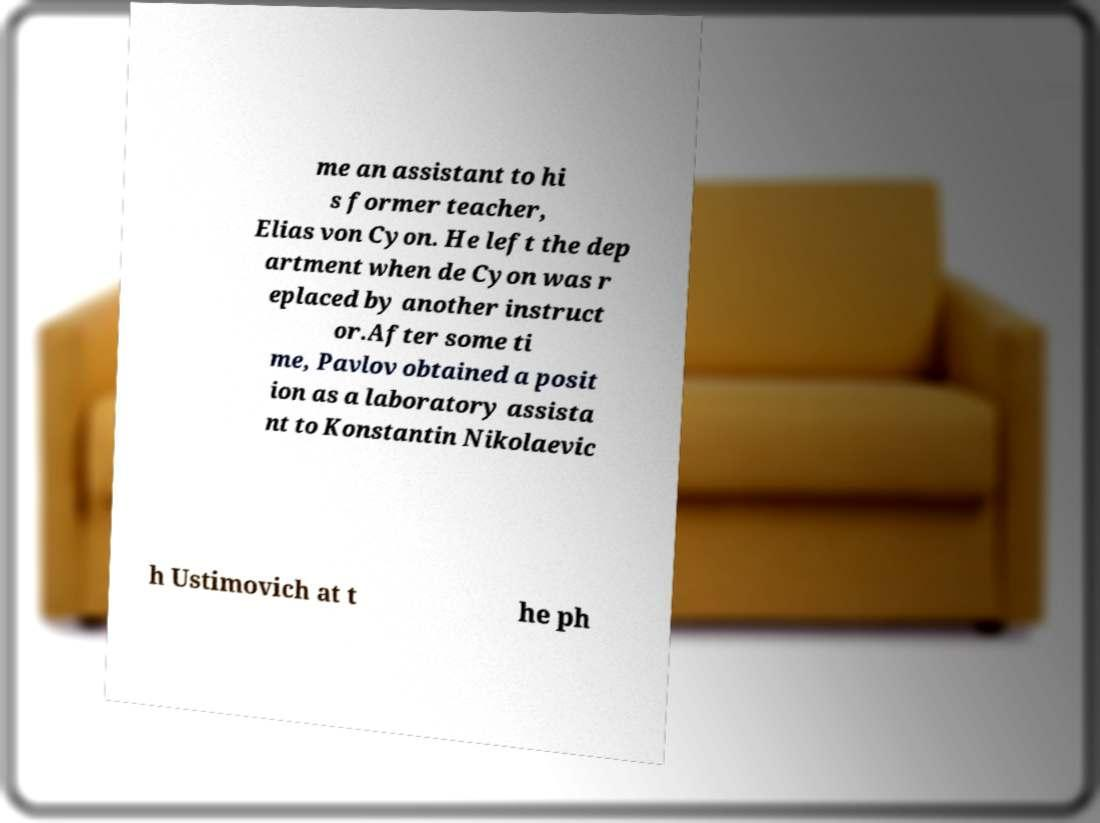Could you assist in decoding the text presented in this image and type it out clearly? me an assistant to hi s former teacher, Elias von Cyon. He left the dep artment when de Cyon was r eplaced by another instruct or.After some ti me, Pavlov obtained a posit ion as a laboratory assista nt to Konstantin Nikolaevic h Ustimovich at t he ph 